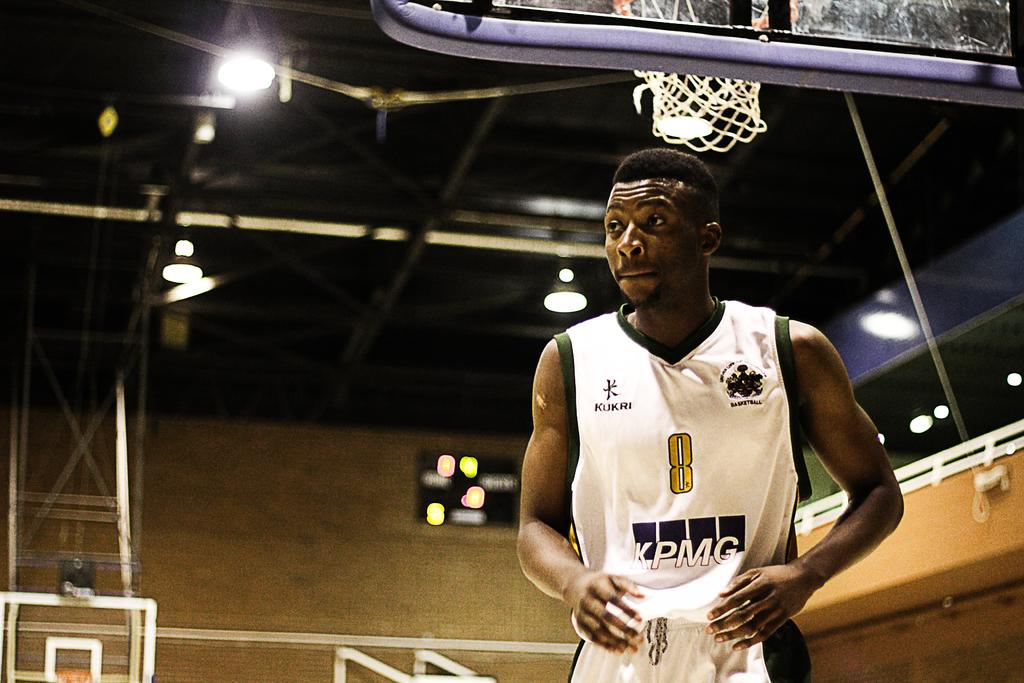<image>
Create a compact narrative representing the image presented. A man is under a basketball hoop with the letters KPMG on his jersey. 